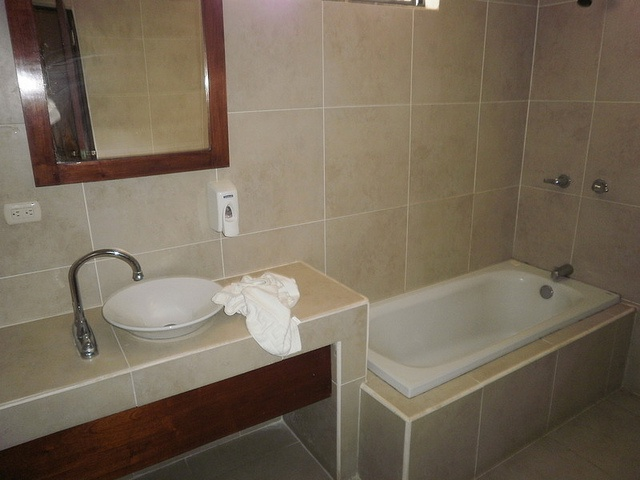Describe the objects in this image and their specific colors. I can see a sink in gray and darkgray tones in this image. 